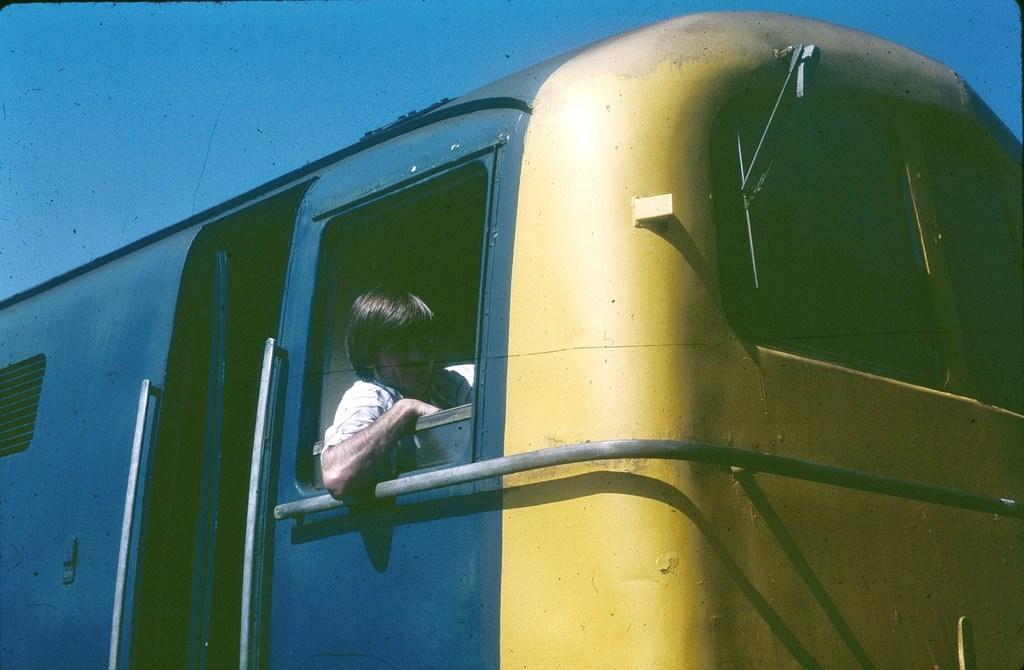Can you describe this image briefly? In this image we can see a person sitting in the motor vehicle. 